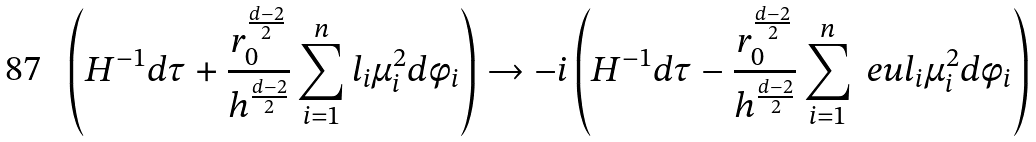Convert formula to latex. <formula><loc_0><loc_0><loc_500><loc_500>\left ( H ^ { - 1 } d \tau + \frac { r _ { 0 } ^ { \frac { d - 2 } { 2 } } } { h ^ { \frac { d - 2 } { 2 } } } \sum _ { i = 1 } ^ { n } l _ { i } \mu _ { i } ^ { 2 } d \phi _ { i } \right ) \rightarrow - i \left ( H ^ { - 1 } d \tau - \frac { r _ { 0 } ^ { \frac { d - 2 } { 2 } } } { h ^ { \frac { d - 2 } { 2 } } } \sum _ { i = 1 } ^ { n } \ e u l _ { i } \mu _ { i } ^ { 2 } d \phi _ { i } \right )</formula> 